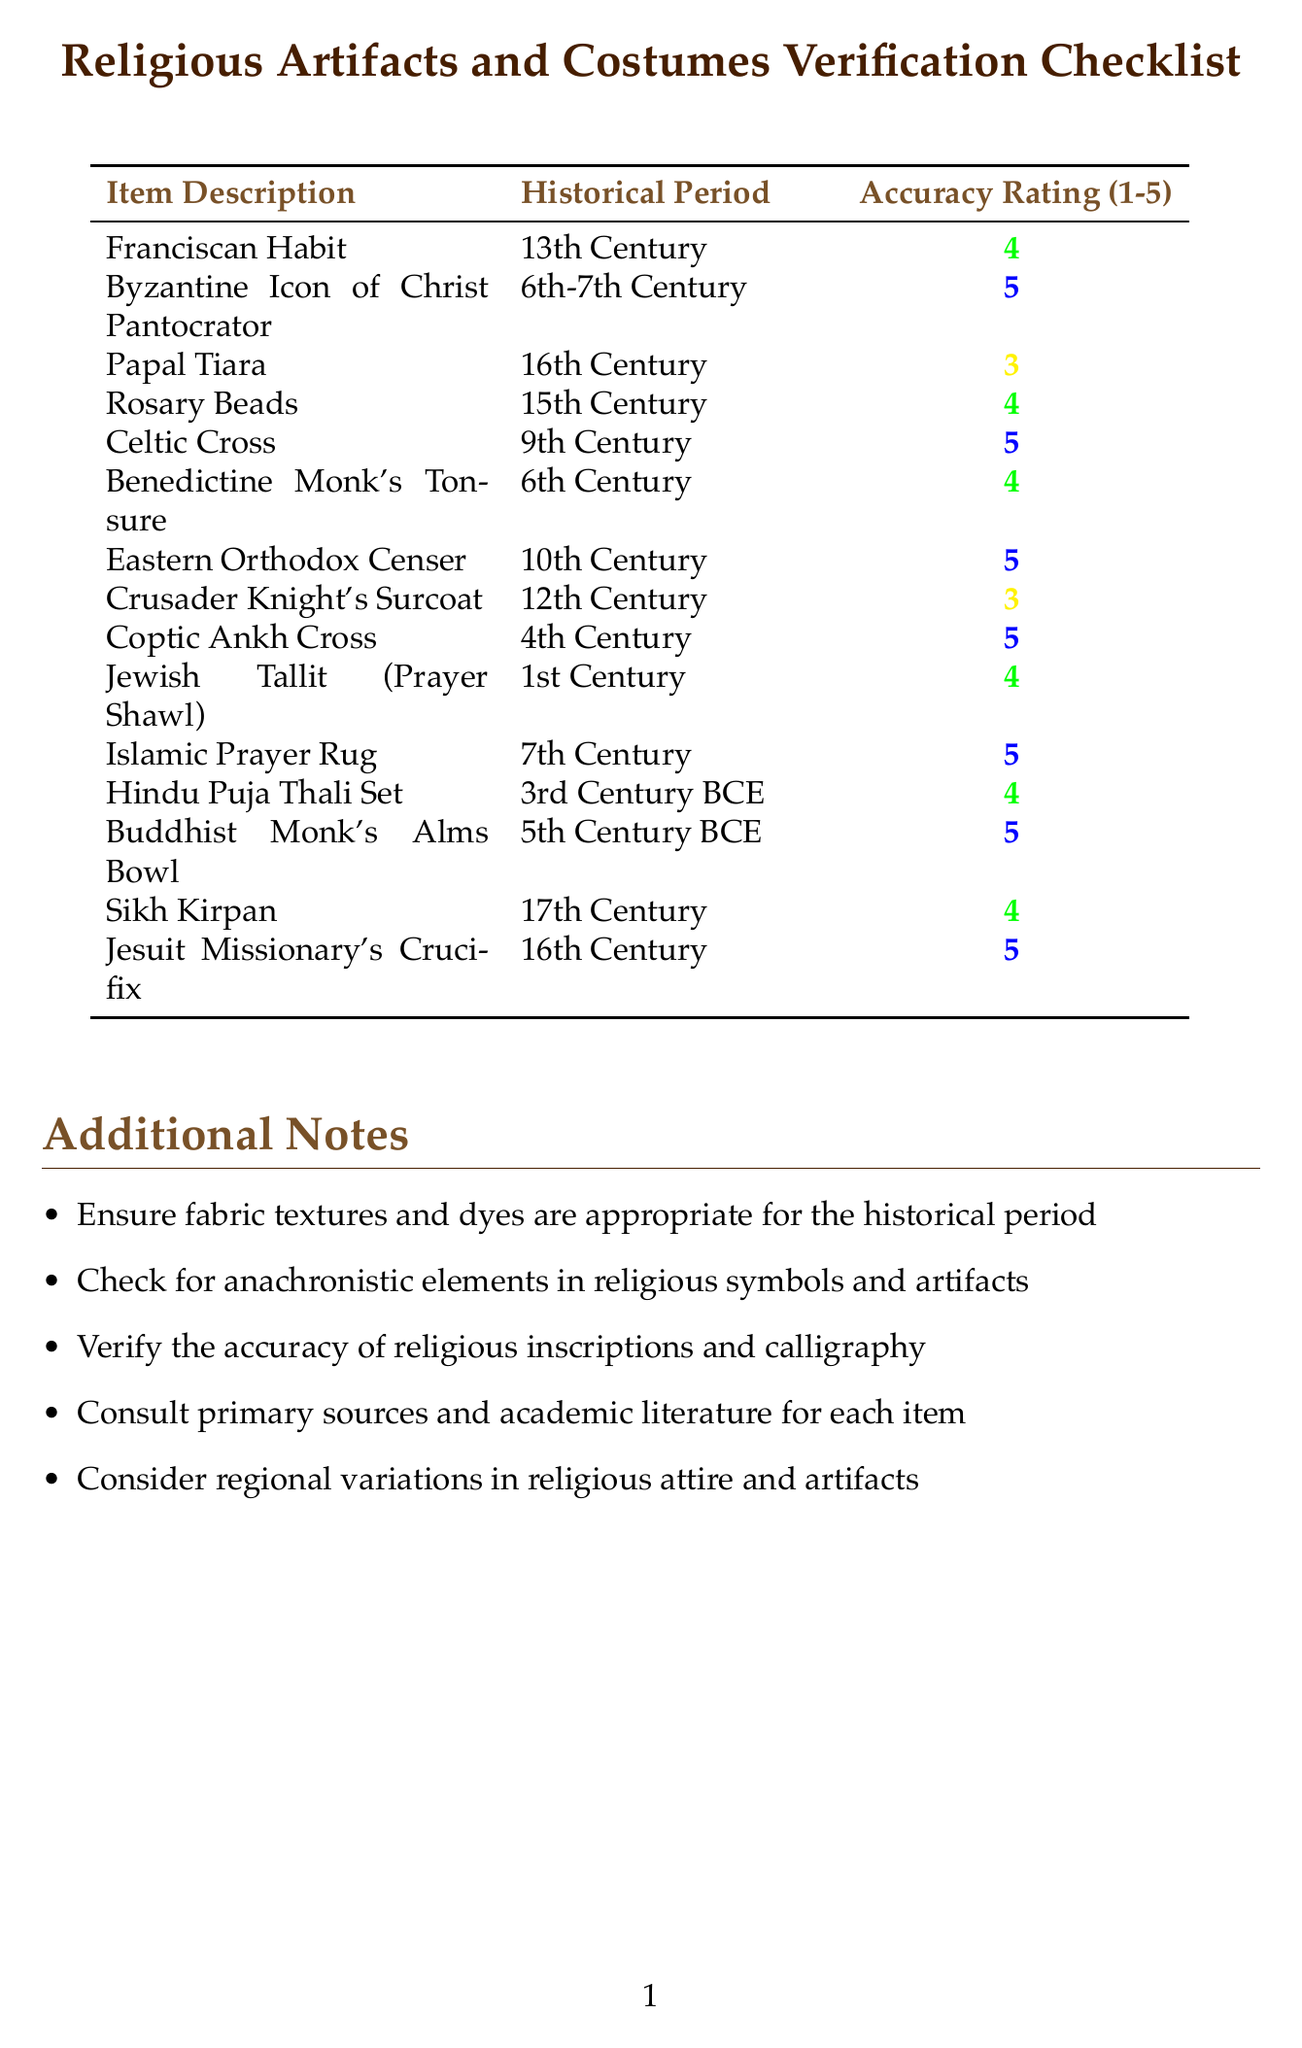What is the accuracy rating of the Byzantine Icon of Christ Pantocrator? The accuracy rating for this item can be found in the checklist under the corresponding item description.
Answer: 5 Which historical period does the Franciscan Habit belong to? The historical period for this item is specified in the checklist alongside its description.
Answer: 13th Century How many items have an accuracy rating of 5? This requires counting the items in the checklist that have an accuracy rating marked with a 5.
Answer: 7 What artifact is associated with the 4th Century? The checklist lists the item descriptions along with their historical periods, highlighting this specific artifact.
Answer: Coptic Ankh Cross What is one of the additional notes regarding the verification? The document includes several notes that provide guidelines for checking the artifacts and costumes.
Answer: Ensure fabric textures and dyes are appropriate for the historical period What is the accuracy rating for the Papal Tiara? The accuracy rating can be directly obtained from the checklist for this item.
Answer: 3 Which item is associated with the 17th Century? This involves finding the item listed in the checklist that corresponds to that specific historical period.
Answer: Sikh Kirpan What is the historical period of the Buddhist Monk's Alms Bowl? The checklist provides the historical periods next to each item description, allowing for direct retrieval.
Answer: 5th Century BCE 